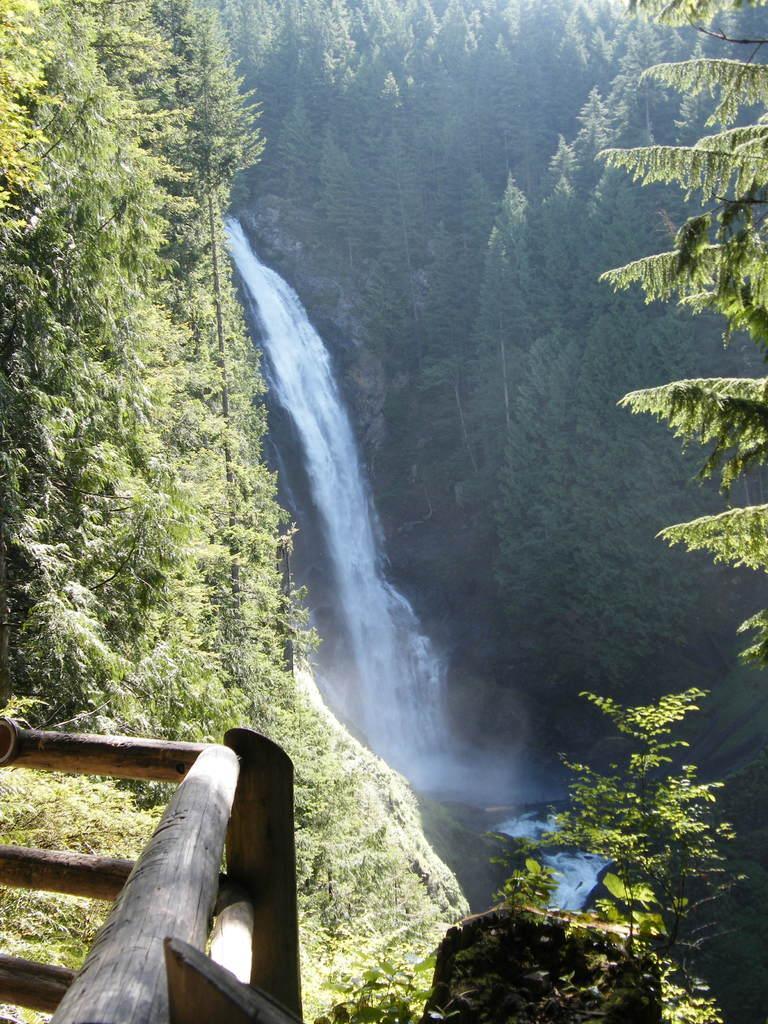Can you describe this image briefly? In this image we can see a waterfall. Also there are trees. In the left bottom corner we can see a fencing with woods. 